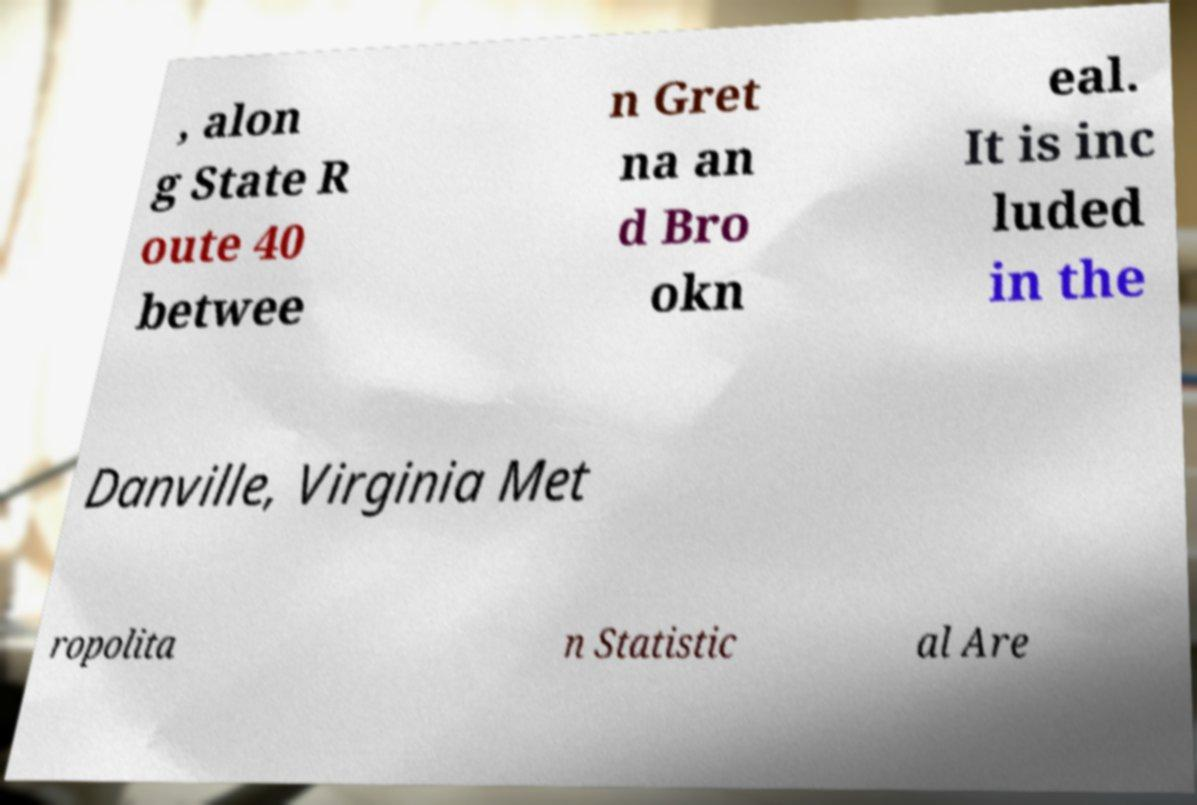There's text embedded in this image that I need extracted. Can you transcribe it verbatim? , alon g State R oute 40 betwee n Gret na an d Bro okn eal. It is inc luded in the Danville, Virginia Met ropolita n Statistic al Are 